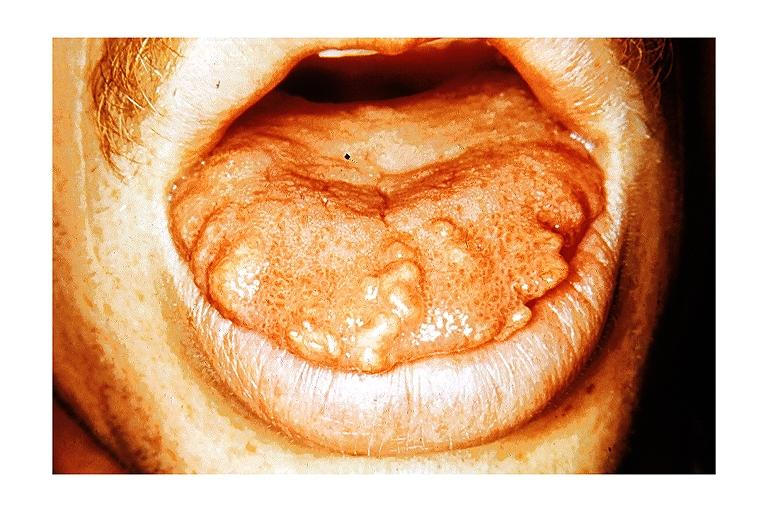what is present?
Answer the question using a single word or phrase. Oral 